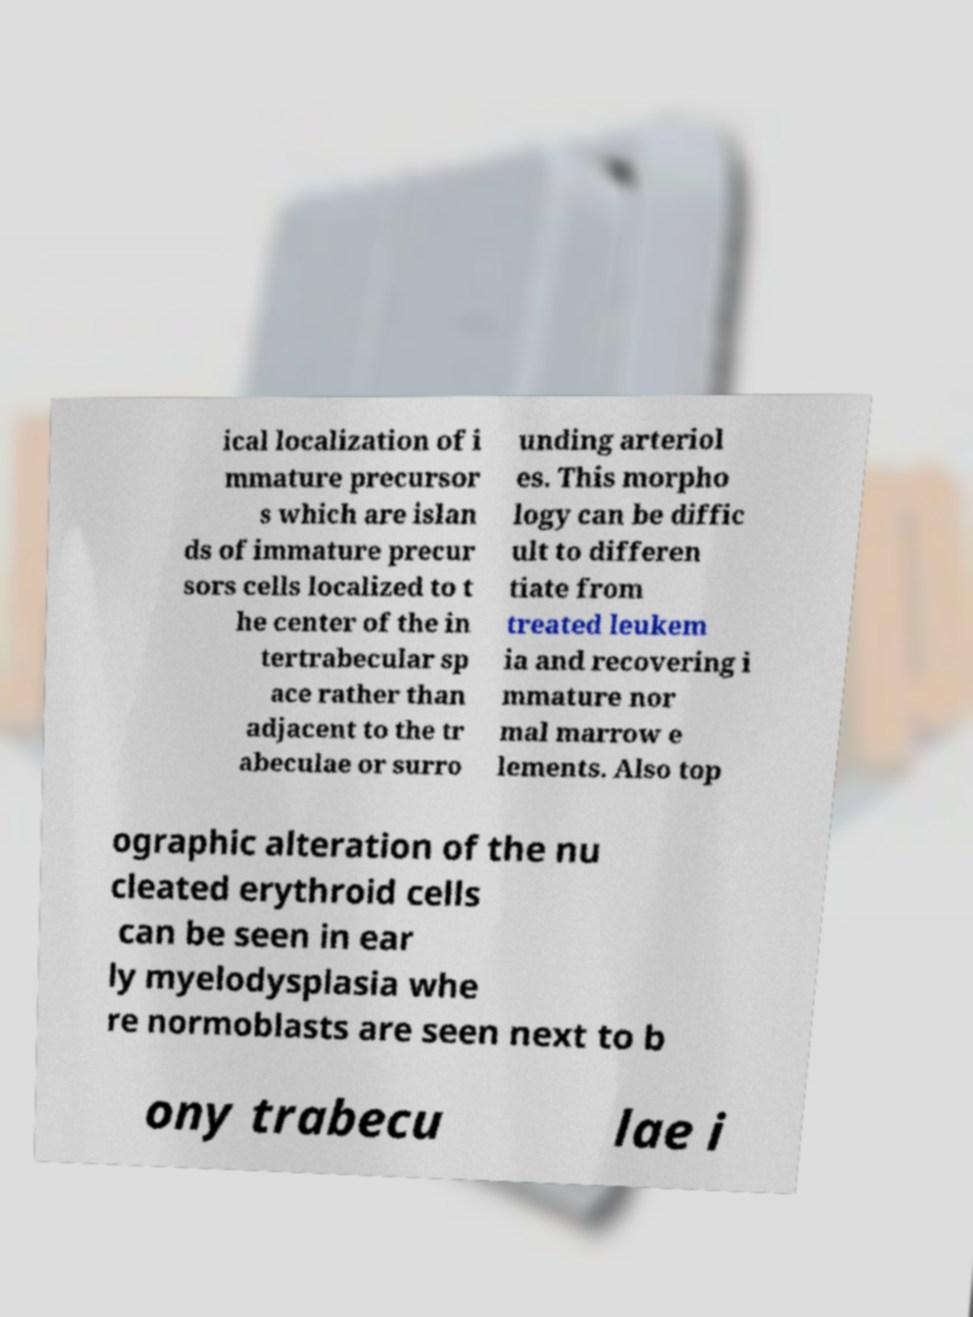I need the written content from this picture converted into text. Can you do that? ical localization of i mmature precursor s which are islan ds of immature precur sors cells localized to t he center of the in tertrabecular sp ace rather than adjacent to the tr abeculae or surro unding arteriol es. This morpho logy can be diffic ult to differen tiate from treated leukem ia and recovering i mmature nor mal marrow e lements. Also top ographic alteration of the nu cleated erythroid cells can be seen in ear ly myelodysplasia whe re normoblasts are seen next to b ony trabecu lae i 